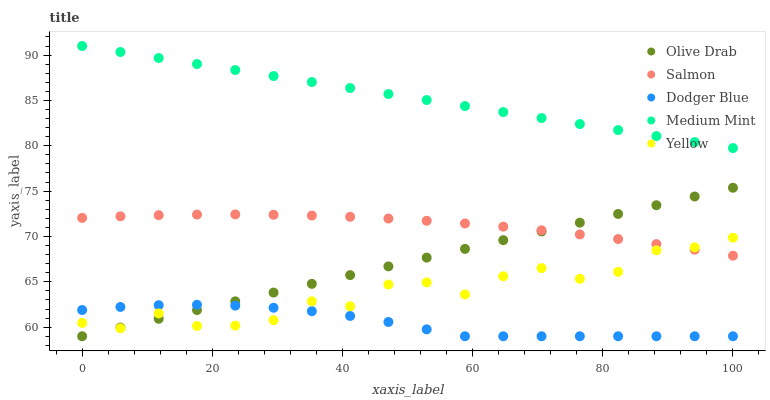Does Dodger Blue have the minimum area under the curve?
Answer yes or no. Yes. Does Medium Mint have the maximum area under the curve?
Answer yes or no. Yes. Does Salmon have the minimum area under the curve?
Answer yes or no. No. Does Salmon have the maximum area under the curve?
Answer yes or no. No. Is Medium Mint the smoothest?
Answer yes or no. Yes. Is Yellow the roughest?
Answer yes or no. Yes. Is Dodger Blue the smoothest?
Answer yes or no. No. Is Dodger Blue the roughest?
Answer yes or no. No. Does Dodger Blue have the lowest value?
Answer yes or no. Yes. Does Salmon have the lowest value?
Answer yes or no. No. Does Medium Mint have the highest value?
Answer yes or no. Yes. Does Salmon have the highest value?
Answer yes or no. No. Is Dodger Blue less than Medium Mint?
Answer yes or no. Yes. Is Salmon greater than Dodger Blue?
Answer yes or no. Yes. Does Salmon intersect Yellow?
Answer yes or no. Yes. Is Salmon less than Yellow?
Answer yes or no. No. Is Salmon greater than Yellow?
Answer yes or no. No. Does Dodger Blue intersect Medium Mint?
Answer yes or no. No. 